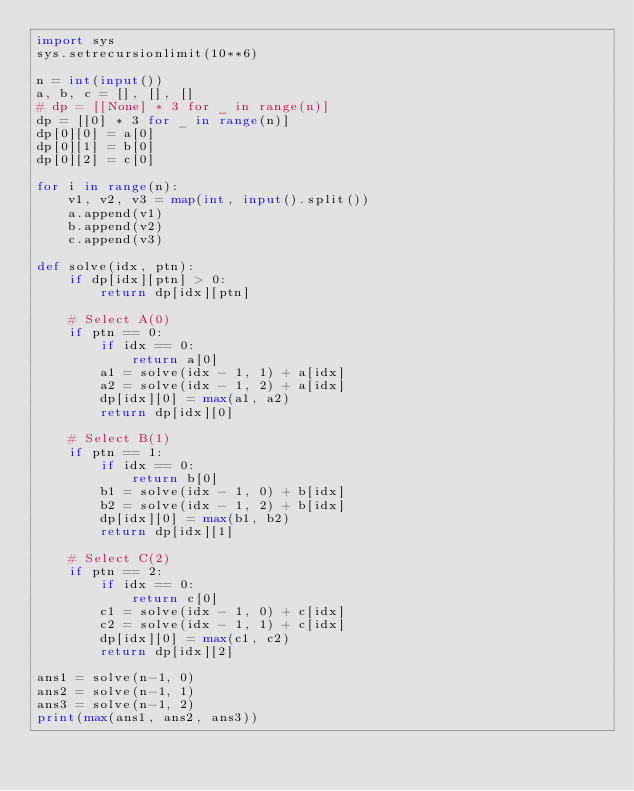Convert code to text. <code><loc_0><loc_0><loc_500><loc_500><_Python_>import sys
sys.setrecursionlimit(10**6)

n = int(input())
a, b, c = [], [], []
# dp = [[None] * 3 for _ in range(n)]
dp = [[0] * 3 for _ in range(n)]
dp[0][0] = a[0]
dp[0][1] = b[0]
dp[0][2] = c[0]

for i in range(n):
    v1, v2, v3 = map(int, input().split())
    a.append(v1)
    b.append(v2)
    c.append(v3)

def solve(idx, ptn):
    if dp[idx][ptn] > 0:
        return dp[idx][ptn]

    # Select A(0)
    if ptn == 0:
        if idx == 0:
            return a[0]
        a1 = solve(idx - 1, 1) + a[idx]
        a2 = solve(idx - 1, 2) + a[idx]
        dp[idx][0] = max(a1, a2)
        return dp[idx][0]

    # Select B(1)
    if ptn == 1:
        if idx == 0:
            return b[0]
        b1 = solve(idx - 1, 0) + b[idx]
        b2 = solve(idx - 1, 2) + b[idx]
        dp[idx][0] = max(b1, b2)
        return dp[idx][1]

    # Select C(2)
    if ptn == 2:
        if idx == 0:
            return c[0]
        c1 = solve(idx - 1, 0) + c[idx]
        c2 = solve(idx - 1, 1) + c[idx]
        dp[idx][0] = max(c1, c2)
        return dp[idx][2]

ans1 = solve(n-1, 0)
ans2 = solve(n-1, 1)
ans3 = solve(n-1, 2)
print(max(ans1, ans2, ans3))
</code> 